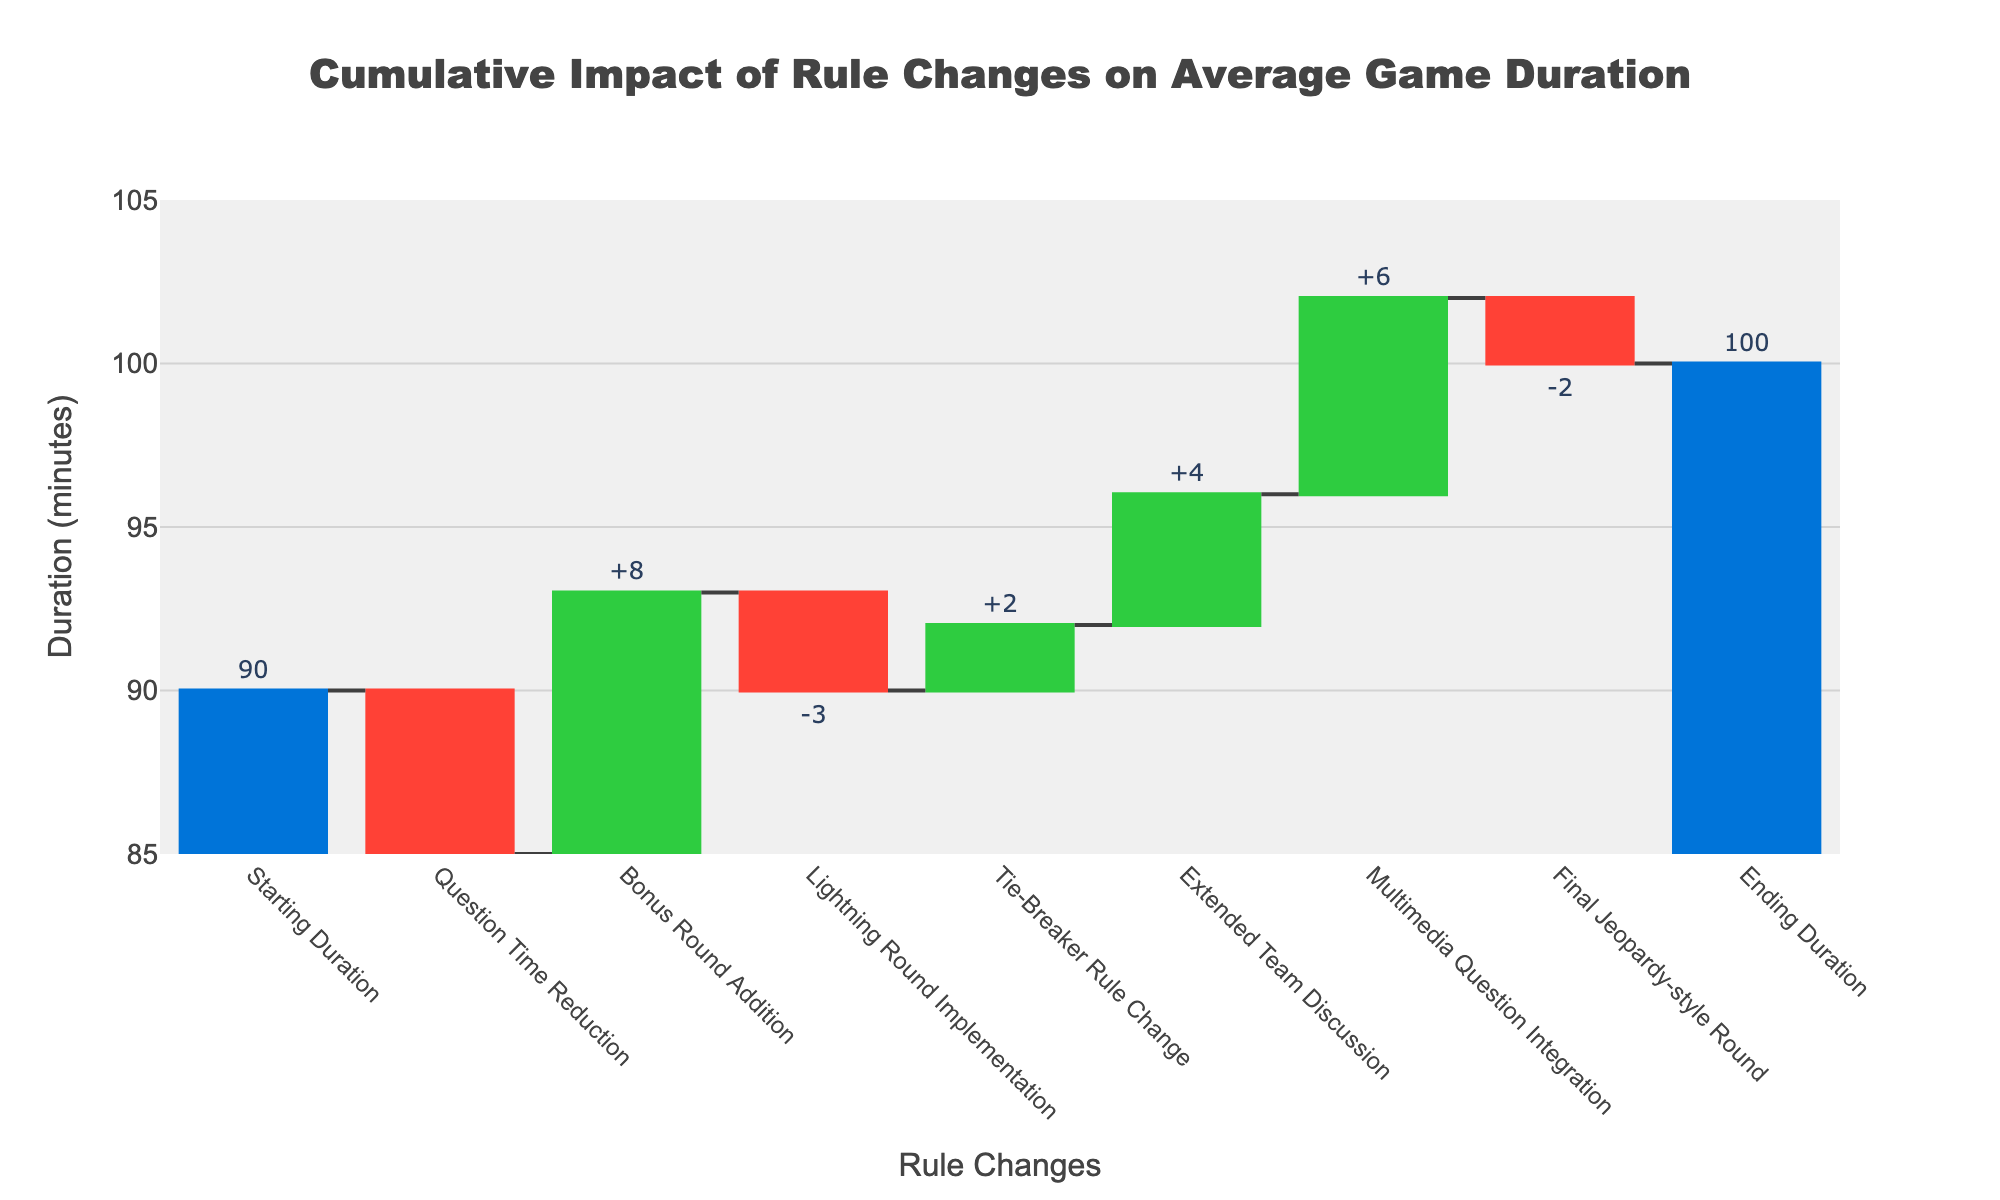What is the title of the chart? The title is displayed at the top of the chart and reads: "Cumulative Impact of Rule Changes on Average Game Duration".
Answer: Cumulative Impact of Rule Changes on Average Game Duration What is the starting game duration before any rule changes? The first bar represents the starting duration with a value label of 90 minutes.
Answer: 90 minutes How much time did the "Multimedia Question Integration" add to the game duration? The increase in duration from "Multimedia Question Integration" is indicated by a green bar with a value of +6 minutes.
Answer: +6 minutes Which rule change had the largest impact on decreasing the game duration? Comparing all the red bars (decreases), "Question Time Reduction" had the largest impact with a value of -5 minutes.
Answer: Question Time Reduction What is the final game duration after all rule changes? The last bar labeled "Ending Duration" shows the final duration, which is 100 minutes.
Answer: 100 minutes What is the combined impact of the "Bonus Round Addition" and "Multimedia Question Integration"? "Bonus Round Addition" adds +8 minutes and "Multimedia Question Integration" adds +6 minutes, so their combined impact is 8 + 6 = 14 minutes.
Answer: 14 minutes How does the "Extended Team Discussion" rule change affect the game duration? The "Extended Team Discussion" rule change increases the duration, represented as a green bar with a value of +4 minutes.
Answer: +4 minutes What is the net impact of "Tie-Breaker Rule Change" and "Final Jeopardy-style Round"? "Tie-Breaker Rule Change" adds +2 minutes and "Final Jeopardy-style Round" subtracts -2 minutes. The net impact is 2 - 2 = 0 minutes.
Answer: 0 minutes Which rule changes decrease the game duration? The rule changes that decrease duration are: "Question Time Reduction" (-5 minutes), "Lightning Round Implementation" (-3 minutes), and "Final Jeopardy-style Round" (-2 minutes).
Answer: Question Time Reduction, Lightning Round Implementation, Final Jeopardy-style Round 